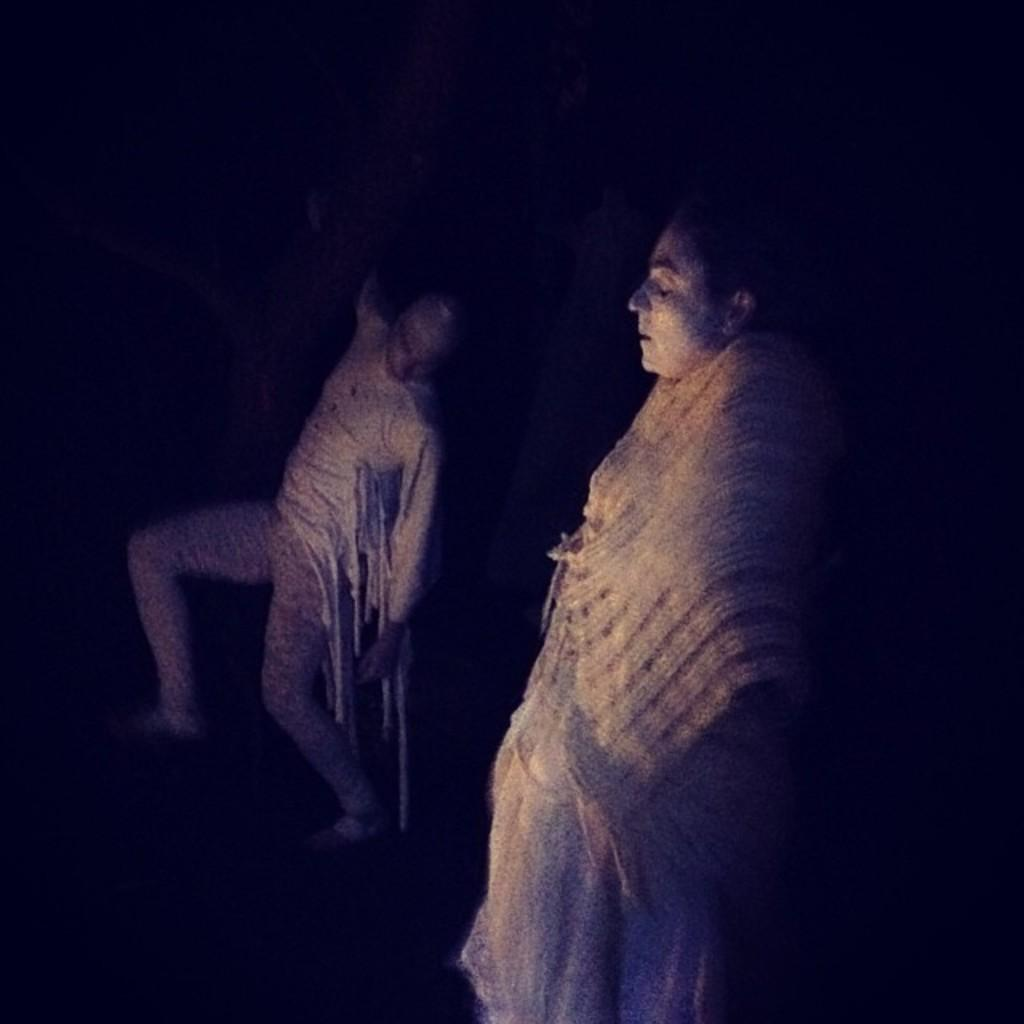How many people are in the image? There are two persons in the image. What can be observed about the background of the image? The background of the image is dark. What decision is the match making in the image? There is no match present in the image, so no decision can be attributed to a match. 